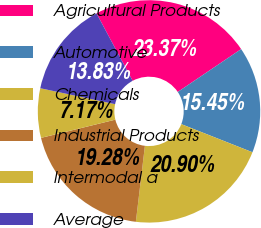<chart> <loc_0><loc_0><loc_500><loc_500><pie_chart><fcel>Agricultural Products<fcel>Automotive<fcel>Chemicals<fcel>Industrial Products<fcel>Intermodal a<fcel>Average<nl><fcel>23.37%<fcel>15.45%<fcel>20.9%<fcel>19.28%<fcel>7.17%<fcel>13.83%<nl></chart> 